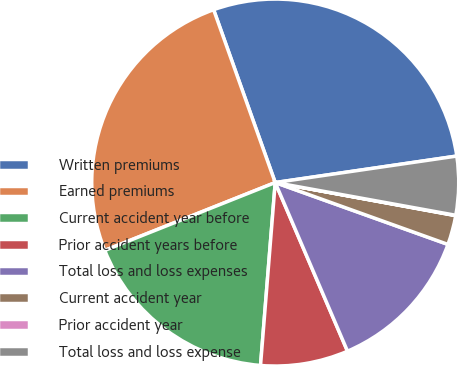<chart> <loc_0><loc_0><loc_500><loc_500><pie_chart><fcel>Written premiums<fcel>Earned premiums<fcel>Current accident year before<fcel>Prior accident years before<fcel>Total loss and loss expenses<fcel>Current accident year<fcel>Prior accident year<fcel>Total loss and loss expense<nl><fcel>28.14%<fcel>25.58%<fcel>17.69%<fcel>7.72%<fcel>13.08%<fcel>2.59%<fcel>0.03%<fcel>5.16%<nl></chart> 